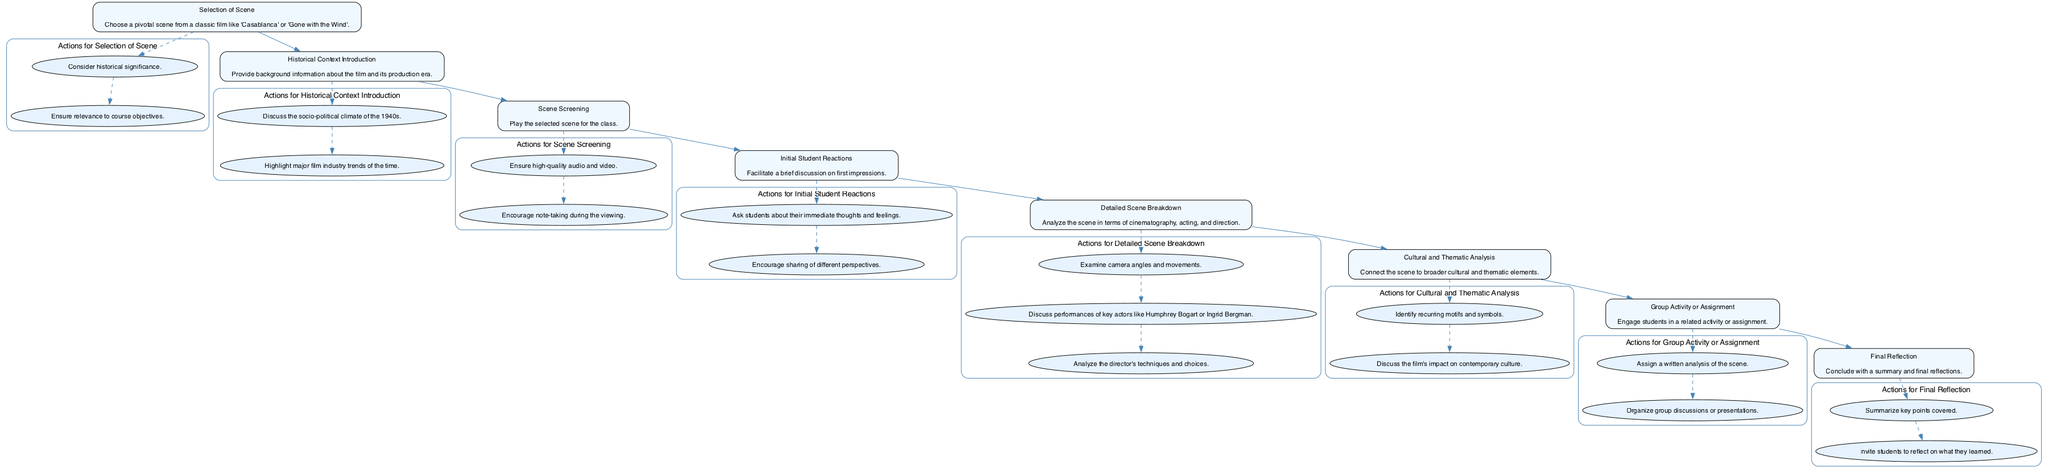What is the first step in the process? The first step mentioned in the diagram is the "Selection of Scene," which initiates the entire analysis and teaching process.
Answer: Selection of Scene How many actions are associated with "Detailed Scene Breakdown"? The diagram shows three actions related to "Detailed Scene Breakdown," which detail various analytical aspects of this step.
Answer: 3 What follows "Initial Student Reactions" in the flow? After "Initial Student Reactions," the next step in the flow is "Detailed Scene Breakdown," indicating a natural progression from gathering impressions to deeper analysis.
Answer: Detailed Scene Breakdown Which film is mentioned as an example for scene selection? "Casablanca" is specifically mentioned as an example in the description of the "Selection of Scene" step in the diagram.
Answer: Casablanca How are the actions for each step organized in the diagram? Each set of actions is organized as a subgraph under its corresponding step, visually grouping them while showing the connection between the step and its actions.
Answer: Subgraph What is the last step in the instructional process? The final step in the process is "Final Reflection," which summarizes and invites student input on their learning experience.
Answer: Final Reflection Which cinematic aspect is discussed in the "Detailed Scene Breakdown"? In the "Detailed Scene Breakdown," specific emphasis is placed on "cinematography," which indicates the focus on visual elements of the selected scene.
Answer: Cinematography How does “Cultural and Thematic Analysis” relate to the overall process? "Cultural and Thematic Analysis" is connected sequentially after "Detailed Scene Breakdown," indicating a move from technical analysis to broader cultural discussions.
Answer: Sequentially What is the purpose of the "Group Activity or Assignment" step? The purpose of the "Group Activity or Assignment" step is to engage students actively, which is essential for reinforcing their understanding of the film scene.
Answer: Engage students actively 